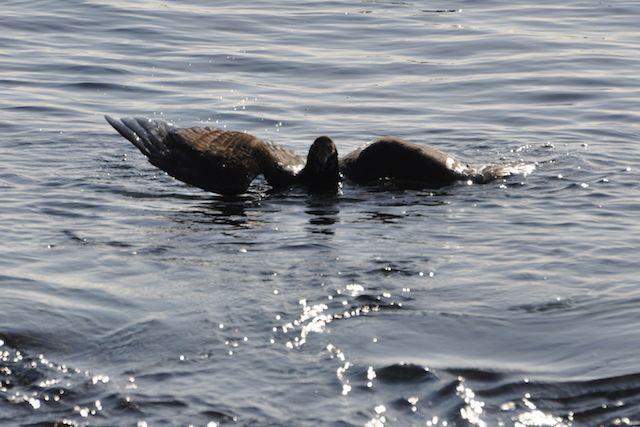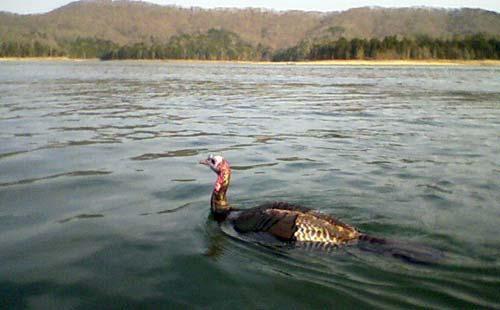The first image is the image on the left, the second image is the image on the right. Given the left and right images, does the statement "An image shows one leftward swimming bird with wings that are not spread." hold true? Answer yes or no. Yes. The first image is the image on the left, the second image is the image on the right. Assess this claim about the two images: "There are two birds, both in water.". Correct or not? Answer yes or no. Yes. 